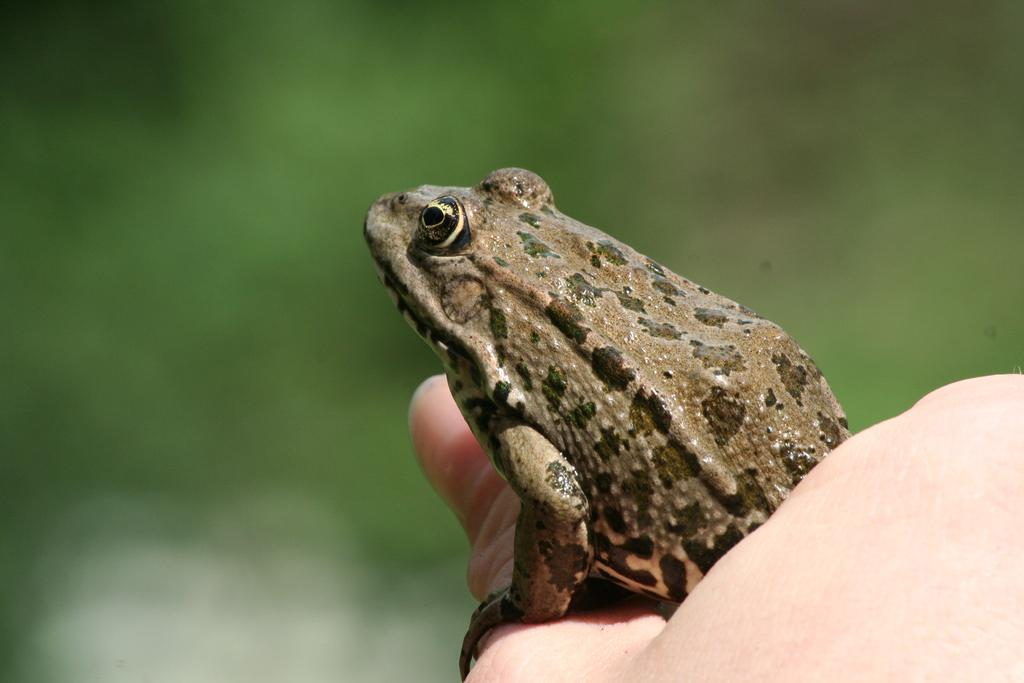What type of animal is present in the image? There is a frog in the image. Can you describe any human presence in the image? A human hand is visible in the image. How many snakes are wrapped around the frog in the image? There are no snakes present in the image; it features a frog and a human hand. What shape does the frog's heart have in the image? The image does not show the frog's heart, so it is not possible to determine its shape. 